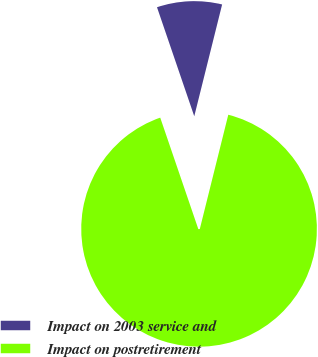<chart> <loc_0><loc_0><loc_500><loc_500><pie_chart><fcel>Impact on 2003 service and<fcel>Impact on postretirement<nl><fcel>9.13%<fcel>90.87%<nl></chart> 